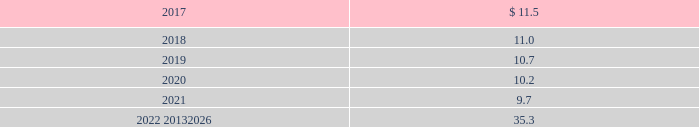Apply as it has no impact on plan obligations .
For 2015 , the healthcare trend rate was 7% ( 7 % ) , the ultimate trend rate was 5% ( 5 % ) , and the year the ultimate trend rate is reached was 2019 .
Projected benefit payments are as follows: .
These estimated benefit payments are based on assumptions about future events .
Actual benefit payments may vary significantly from these estimates .
17 .
Commitments and contingencies litigation we are involved in various legal proceedings , including commercial , competition , environmental , health , safety , product liability , and insurance matters .
In september 2010 , the brazilian administrative council for economic defense ( cade ) issued a decision against our brazilian subsidiary , air products brasil ltda. , and several other brazilian industrial gas companies for alleged anticompetitive activities .
Cade imposed a civil fine of r$ 179.2 million ( approximately $ 55 at 30 september 2016 ) on air products brasil ltda .
This fine was based on a recommendation by a unit of the brazilian ministry of justice , whose investigation began in 2003 , alleging violation of competition laws with respect to the sale of industrial and medical gases .
The fines are based on a percentage of our total revenue in brazil in 2003 .
We have denied the allegations made by the authorities and filed an appeal in october 2010 with the brazilian courts .
On 6 may 2014 , our appeal was granted and the fine against air products brasil ltda .
Was dismissed .
Cade has appealed that ruling and the matter remains pending .
We , with advice of our outside legal counsel , have assessed the status of this matter and have concluded that , although an adverse final judgment after exhausting all appeals is possible , such a judgment is not probable .
As a result , no provision has been made in the consolidated financial statements .
We estimate the maximum possible loss to be the full amount of the fine of r$ 179.2 million ( approximately $ 55 at 30 september 2016 ) plus interest accrued thereon until final disposition of the proceedings .
Other than this matter , we do not currently believe there are any legal proceedings , individually or in the aggregate , that are reasonably possible to have a material impact on our financial condition , results of operations , or cash flows .
Environmental in the normal course of business , we are involved in legal proceedings under the comprehensive environmental response , compensation , and liability act ( cercla : the federal superfund law ) ; resource conservation and recovery act ( rcra ) ; and similar state and foreign environmental laws relating to the designation of certain sites for investigation or remediation .
Presently , there are approximately 33 sites on which a final settlement has not been reached where we , along with others , have been designated a potentially responsible party by the environmental protection agency or are otherwise engaged in investigation or remediation , including cleanup activity at certain of our current and former manufacturing sites .
We continually monitor these sites for which we have environmental exposure .
Accruals for environmental loss contingencies are recorded when it is probable that a liability has been incurred and the amount of loss can be reasonably estimated .
The consolidated balance sheets at 30 september 2016 and 2015 included an accrual of $ 81.4 and $ 80.6 , respectively , primarily as part of other noncurrent liabilities .
The environmental liabilities will be paid over a period of up to 30 years .
We estimate the exposure for environmental loss contingencies to range from $ 81 to a reasonably possible upper exposure of $ 95 as of 30 september 2016. .
Considering the 2022-2026 period , what is the annual projected benefit payment value? 
Rationale: it is the sum of all these years' projected benefit payments divided by five ( number of years ) .
Computations: (35.3 / 5)
Answer: 7.06. 